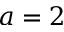<formula> <loc_0><loc_0><loc_500><loc_500>a = 2</formula> 